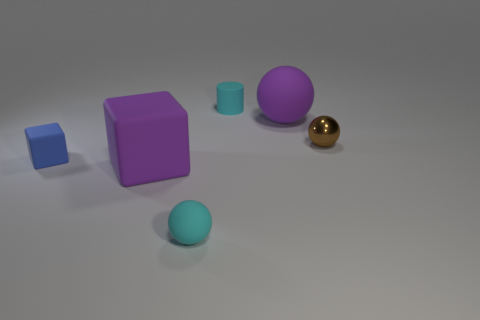How many things are to the left of the brown object and right of the blue thing?
Offer a terse response. 4. Is the number of tiny cyan matte cylinders to the left of the blue rubber thing the same as the number of large purple rubber objects in front of the cyan rubber ball?
Your response must be concise. Yes. There is a purple rubber thing that is to the right of the purple rubber cube; is its size the same as the cyan thing that is behind the purple sphere?
Provide a succinct answer. No. What material is the sphere that is both left of the small brown metal object and behind the small cyan rubber ball?
Your answer should be compact. Rubber. Is the number of shiny spheres less than the number of cyan things?
Provide a succinct answer. Yes. There is a purple thing left of the tiny sphere that is in front of the blue block; what is its size?
Your answer should be very brief. Large. There is a small cyan matte thing that is behind the purple rubber thing that is behind the purple object in front of the tiny blue block; what shape is it?
Your response must be concise. Cylinder. The big block that is made of the same material as the tiny cylinder is what color?
Offer a terse response. Purple. What color is the big object that is to the left of the cyan object behind the rubber thing that is right of the tiny cyan cylinder?
Keep it short and to the point. Purple. What number of blocks are either things or purple matte objects?
Your answer should be very brief. 2. 